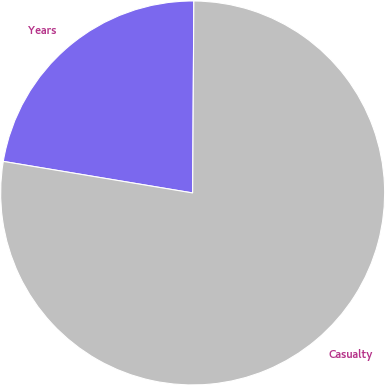Convert chart to OTSL. <chart><loc_0><loc_0><loc_500><loc_500><pie_chart><fcel>Years<fcel>Casualty<nl><fcel>22.47%<fcel>77.53%<nl></chart> 